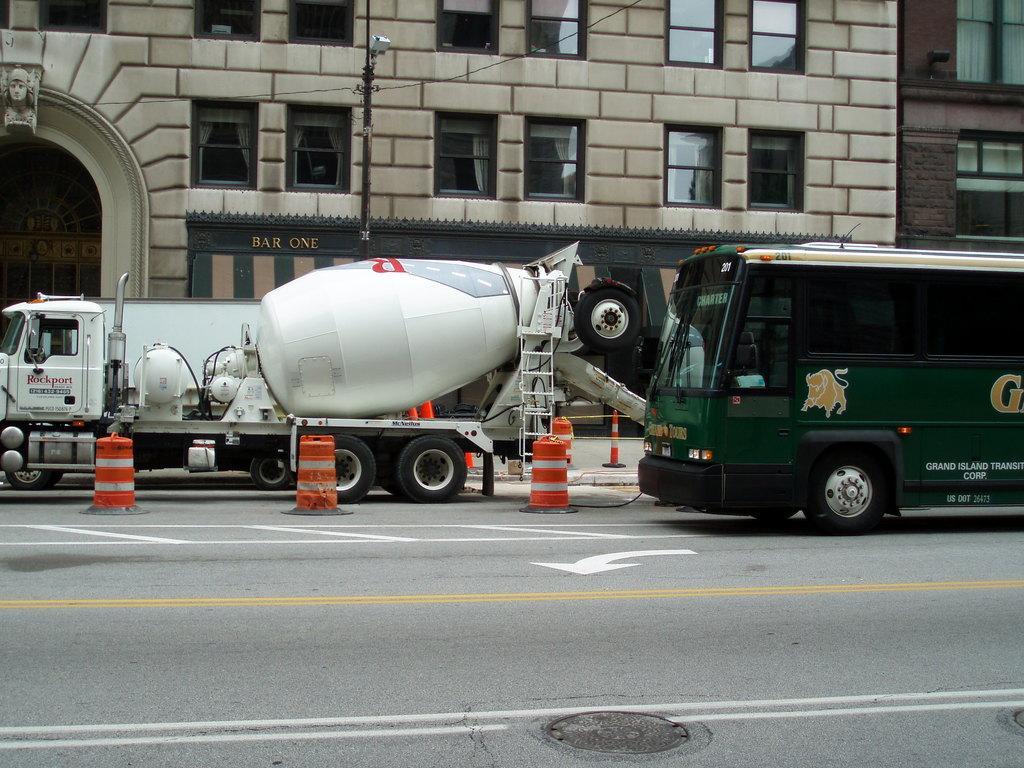In one or two sentences, can you explain what this image depicts? In this image two vehicles are on the road having few inverted cones. Background there is a building having windows and a door. Left top there is a sculpture attached to the wall of a building. Behind the vehicle there is a pole having a lamp. A wire is connected to it. 